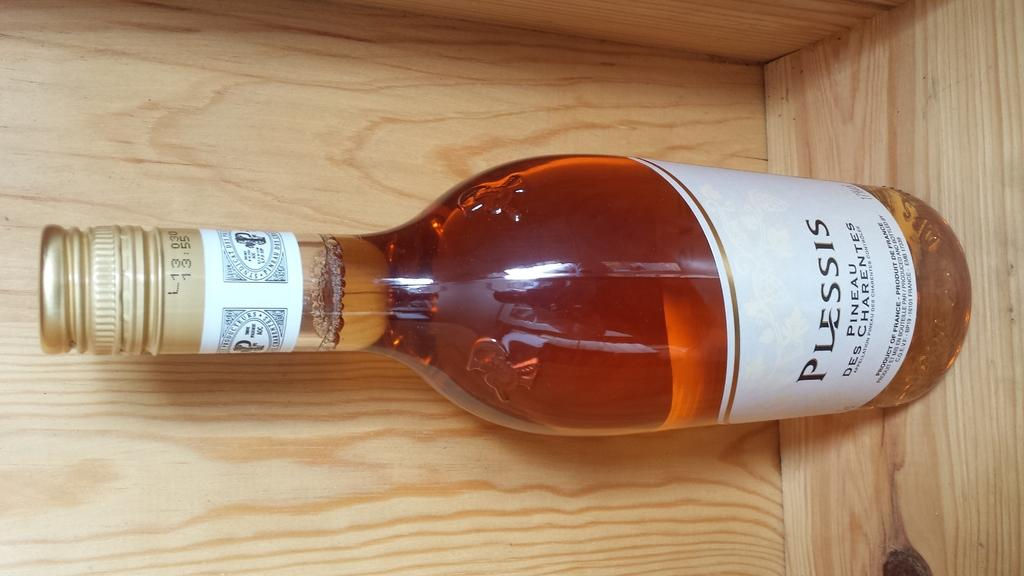<image>
Give a short and clear explanation of the subsequent image. A full bottle of Plessis Pineau from France 